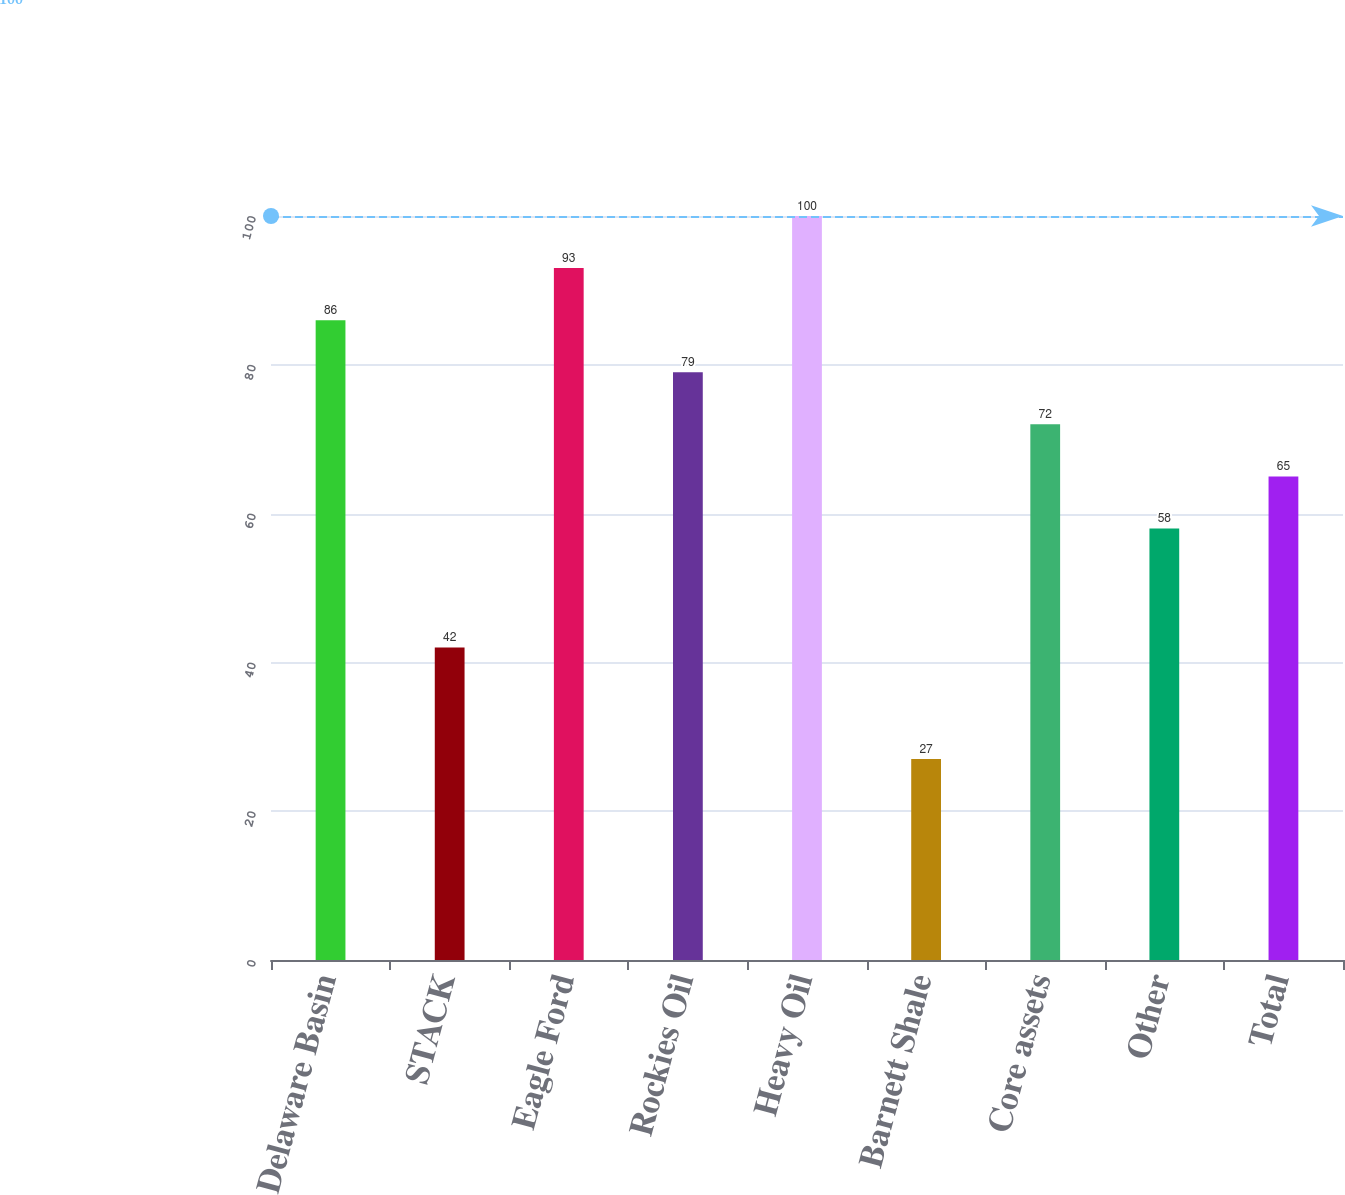<chart> <loc_0><loc_0><loc_500><loc_500><bar_chart><fcel>Delaware Basin<fcel>STACK<fcel>Eagle Ford<fcel>Rockies Oil<fcel>Heavy Oil<fcel>Barnett Shale<fcel>Core assets<fcel>Other<fcel>Total<nl><fcel>86<fcel>42<fcel>93<fcel>79<fcel>100<fcel>27<fcel>72<fcel>58<fcel>65<nl></chart> 